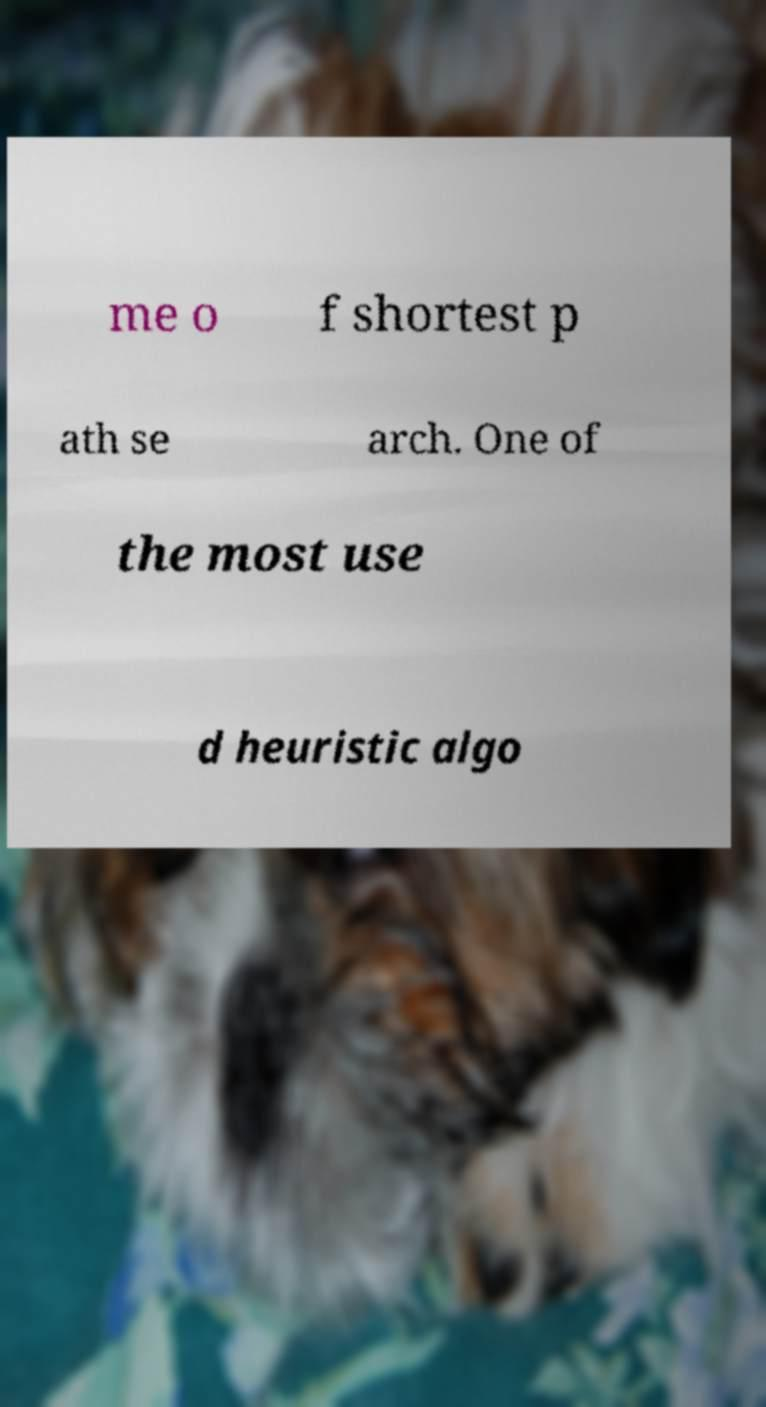Could you assist in decoding the text presented in this image and type it out clearly? me o f shortest p ath se arch. One of the most use d heuristic algo 